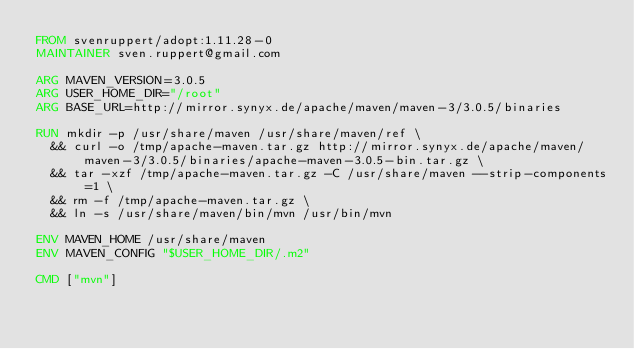Convert code to text. <code><loc_0><loc_0><loc_500><loc_500><_Dockerfile_>FROM svenruppert/adopt:1.11.28-0
MAINTAINER sven.ruppert@gmail.com

ARG MAVEN_VERSION=3.0.5
ARG USER_HOME_DIR="/root"
ARG BASE_URL=http://mirror.synyx.de/apache/maven/maven-3/3.0.5/binaries

RUN mkdir -p /usr/share/maven /usr/share/maven/ref \
  && curl -o /tmp/apache-maven.tar.gz http://mirror.synyx.de/apache/maven/maven-3/3.0.5/binaries/apache-maven-3.0.5-bin.tar.gz \
  && tar -xzf /tmp/apache-maven.tar.gz -C /usr/share/maven --strip-components=1 \
  && rm -f /tmp/apache-maven.tar.gz \
  && ln -s /usr/share/maven/bin/mvn /usr/bin/mvn

ENV MAVEN_HOME /usr/share/maven
ENV MAVEN_CONFIG "$USER_HOME_DIR/.m2"

CMD ["mvn"]</code> 